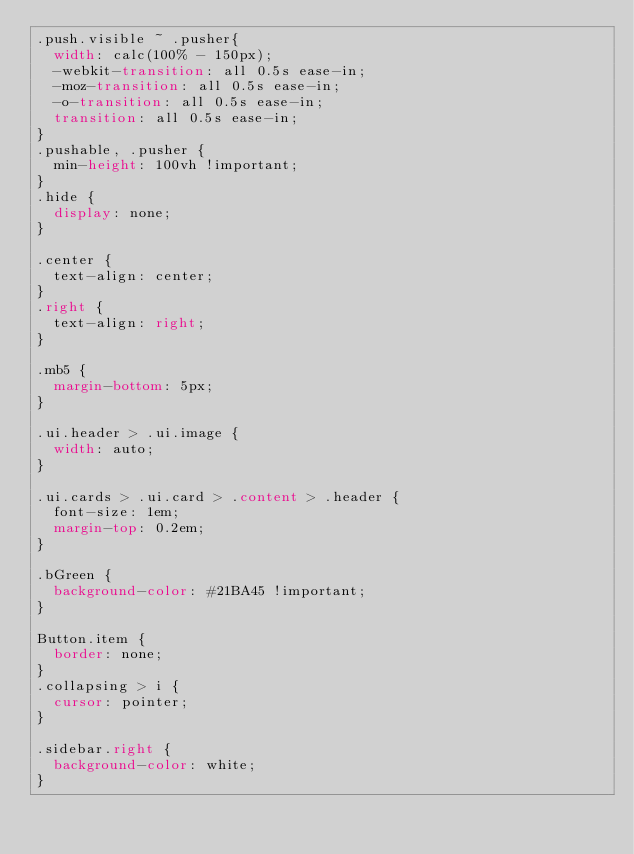Convert code to text. <code><loc_0><loc_0><loc_500><loc_500><_CSS_>.push.visible ~ .pusher{
  width: calc(100% - 150px);
  -webkit-transition: all 0.5s ease-in;
  -moz-transition: all 0.5s ease-in;
  -o-transition: all 0.5s ease-in;
  transition: all 0.5s ease-in;
}
.pushable, .pusher {
  min-height: 100vh !important;
}
.hide {
  display: none;
}

.center {
  text-align: center;
}
.right {
  text-align: right;
}

.mb5 {
  margin-bottom: 5px;
}

.ui.header > .ui.image {
  width: auto;
}

.ui.cards > .ui.card > .content > .header {
  font-size: 1em;
  margin-top: 0.2em;
}

.bGreen {
  background-color: #21BA45 !important;
}

Button.item {
  border: none;
}
.collapsing > i {
  cursor: pointer;
}

.sidebar.right {
  background-color: white;
}</code> 